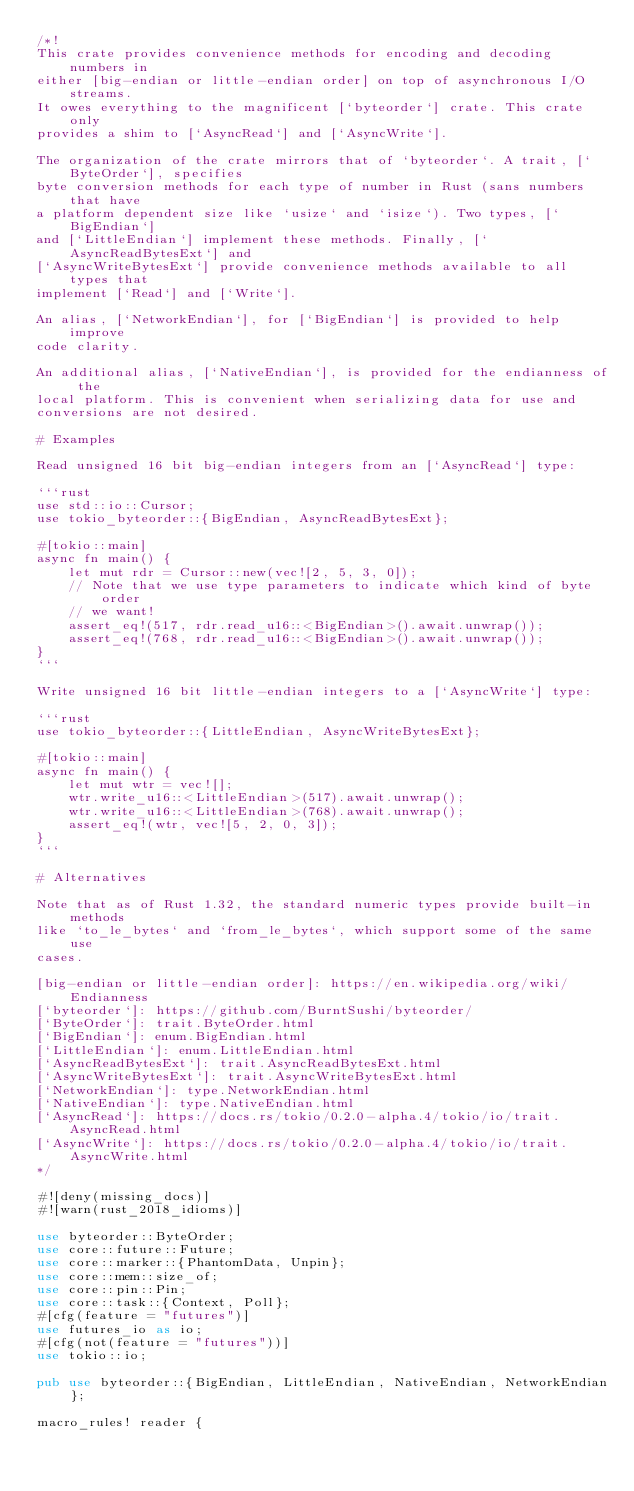Convert code to text. <code><loc_0><loc_0><loc_500><loc_500><_Rust_>/*!
This crate provides convenience methods for encoding and decoding numbers in
either [big-endian or little-endian order] on top of asynchronous I/O streams.
It owes everything to the magnificent [`byteorder`] crate. This crate only
provides a shim to [`AsyncRead`] and [`AsyncWrite`].

The organization of the crate mirrors that of `byteorder`. A trait, [`ByteOrder`], specifies
byte conversion methods for each type of number in Rust (sans numbers that have
a platform dependent size like `usize` and `isize`). Two types, [`BigEndian`]
and [`LittleEndian`] implement these methods. Finally, [`AsyncReadBytesExt`] and
[`AsyncWriteBytesExt`] provide convenience methods available to all types that
implement [`Read`] and [`Write`].

An alias, [`NetworkEndian`], for [`BigEndian`] is provided to help improve
code clarity.

An additional alias, [`NativeEndian`], is provided for the endianness of the
local platform. This is convenient when serializing data for use and
conversions are not desired.

# Examples

Read unsigned 16 bit big-endian integers from an [`AsyncRead`] type:

```rust
use std::io::Cursor;
use tokio_byteorder::{BigEndian, AsyncReadBytesExt};

#[tokio::main]
async fn main() {
    let mut rdr = Cursor::new(vec![2, 5, 3, 0]);
    // Note that we use type parameters to indicate which kind of byte order
    // we want!
    assert_eq!(517, rdr.read_u16::<BigEndian>().await.unwrap());
    assert_eq!(768, rdr.read_u16::<BigEndian>().await.unwrap());
}
```

Write unsigned 16 bit little-endian integers to a [`AsyncWrite`] type:

```rust
use tokio_byteorder::{LittleEndian, AsyncWriteBytesExt};

#[tokio::main]
async fn main() {
    let mut wtr = vec![];
    wtr.write_u16::<LittleEndian>(517).await.unwrap();
    wtr.write_u16::<LittleEndian>(768).await.unwrap();
    assert_eq!(wtr, vec![5, 2, 0, 3]);
}
```

# Alternatives

Note that as of Rust 1.32, the standard numeric types provide built-in methods
like `to_le_bytes` and `from_le_bytes`, which support some of the same use
cases.

[big-endian or little-endian order]: https://en.wikipedia.org/wiki/Endianness
[`byteorder`]: https://github.com/BurntSushi/byteorder/
[`ByteOrder`]: trait.ByteOrder.html
[`BigEndian`]: enum.BigEndian.html
[`LittleEndian`]: enum.LittleEndian.html
[`AsyncReadBytesExt`]: trait.AsyncReadBytesExt.html
[`AsyncWriteBytesExt`]: trait.AsyncWriteBytesExt.html
[`NetworkEndian`]: type.NetworkEndian.html
[`NativeEndian`]: type.NativeEndian.html
[`AsyncRead`]: https://docs.rs/tokio/0.2.0-alpha.4/tokio/io/trait.AsyncRead.html
[`AsyncWrite`]: https://docs.rs/tokio/0.2.0-alpha.4/tokio/io/trait.AsyncWrite.html
*/

#![deny(missing_docs)]
#![warn(rust_2018_idioms)]

use byteorder::ByteOrder;
use core::future::Future;
use core::marker::{PhantomData, Unpin};
use core::mem::size_of;
use core::pin::Pin;
use core::task::{Context, Poll};
#[cfg(feature = "futures")]
use futures_io as io;
#[cfg(not(feature = "futures"))]
use tokio::io;

pub use byteorder::{BigEndian, LittleEndian, NativeEndian, NetworkEndian};

macro_rules! reader {</code> 